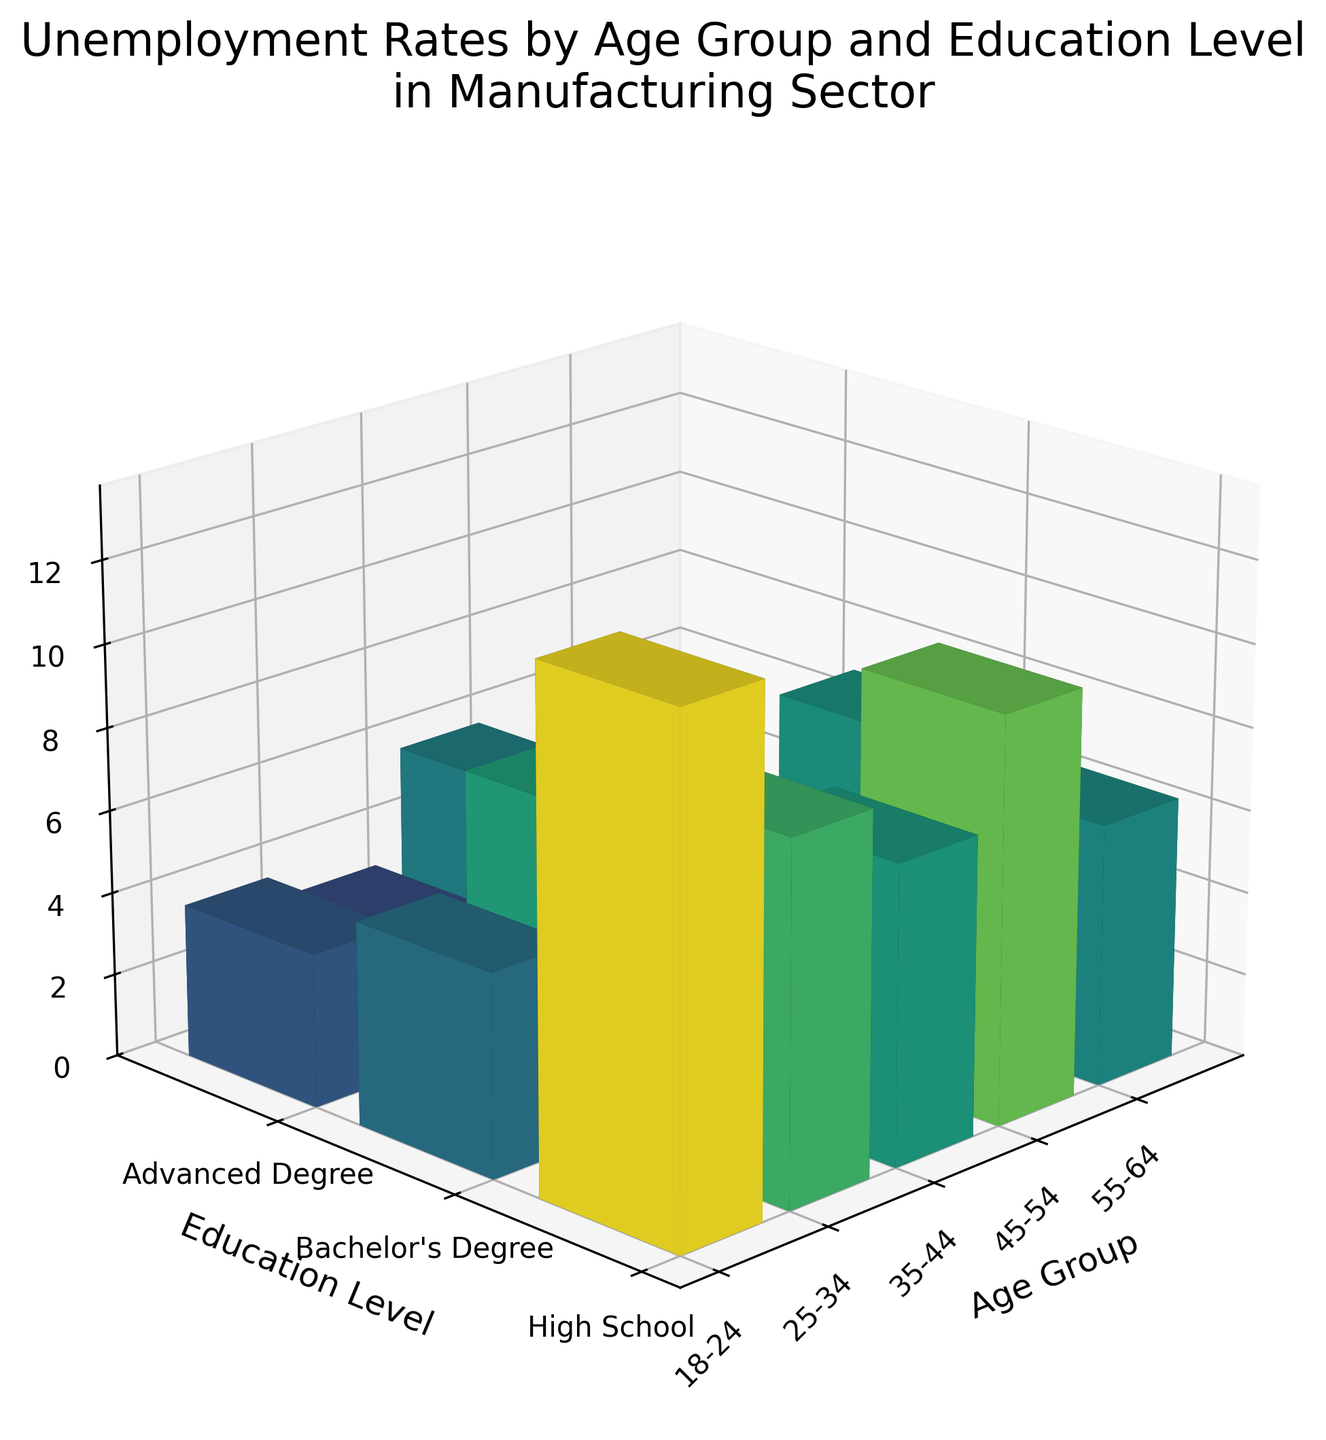what is the title of the plot? The plot title can be found at the top of the figure, usually in a larger and bolder font than other text.
Answer: Unemployment Rates by Age Group and Education Level in Manufacturing Sector which age group has the highest unemployment rate? Look for the highest bar on the 3D plot and identify the corresponding age group label on the x-axis.
Answer: 18-24 what is the average unemployment rate for the 25-34 age group? Find the bars corresponding to the 25-34 age group and calculate the average of their heights (unemployment rates). The rates are 9.8, 6.3, and 4.9. Sum these rates and divide by the count of data points (3). (9.8+6.3+4.9)/3 = 7.0
Answer: 7.0 how does the unemployment rate for individuals with a high school diploma change with age? Identify the bars corresponding to "High School" on the y-axis and note the change in bar heights (unemployment rates) as you move along the x-axis (various age groups).
Answer: Decreases with age which education level consistently has the lowest unemployment rates across all age groups? Compare the heights of bars for "High School," "Bachelor’s Degree," and "Advanced Degree" across all age groups. The shortest bars represent the lowest rates.
Answer: Advanced Degree how much higher is the unemployment rate for 18-24-year-olds with a high school diploma compared to those with a bachelor’s degree? Find the unemployment rate bars for 18-24-year-olds with a high school diploma and a bachelor’s degree, then subtract the height of the bachelor's degree bar from the high school bar. The rates are 12.5 (High School) and 8.7 (Bachelor's Degree). 12.5 - 8.7 = 3.8
Answer: 3.8 what is the unemployment rate for 45-54-year-olds with an advanced degree? Find the bar corresponding to the 45-54 age group and "Advanced Degree" on the y-axis, and note its height.
Answer: 3.1 which age group shows the greatest variation in unemployment rates across different education levels? Identify the range of unemployment rates within each age group by subtracting the lowest rate from the highest rate. The age group with the largest range shows the greatest variation.
Answer: 18-24 how do the unemployment rates for high school graduates compare between 18-24 and 55-64 age groups? Look at the heights of the bars representing high school graduates in the 18-24 and 55-64 age groups and compare their values.
Answer: Higher for 18-24 what is the overall trend in unemployment rates as education level increases within each age group? Observe the heights of the bars from "High School" to "Bachelor’s Degree" to "Advanced Degree" within each age group and note the general direction (increase or decrease) of the bars' heights.
Answer: Decreases with higher education levels 